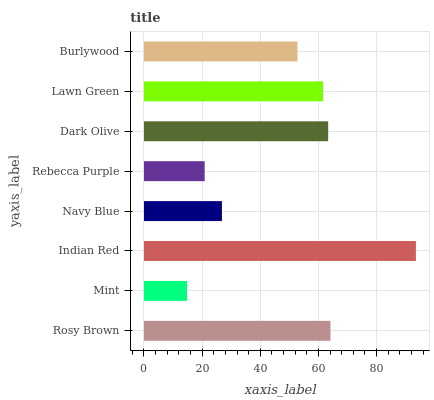Is Mint the minimum?
Answer yes or no. Yes. Is Indian Red the maximum?
Answer yes or no. Yes. Is Indian Red the minimum?
Answer yes or no. No. Is Mint the maximum?
Answer yes or no. No. Is Indian Red greater than Mint?
Answer yes or no. Yes. Is Mint less than Indian Red?
Answer yes or no. Yes. Is Mint greater than Indian Red?
Answer yes or no. No. Is Indian Red less than Mint?
Answer yes or no. No. Is Lawn Green the high median?
Answer yes or no. Yes. Is Burlywood the low median?
Answer yes or no. Yes. Is Rosy Brown the high median?
Answer yes or no. No. Is Rosy Brown the low median?
Answer yes or no. No. 